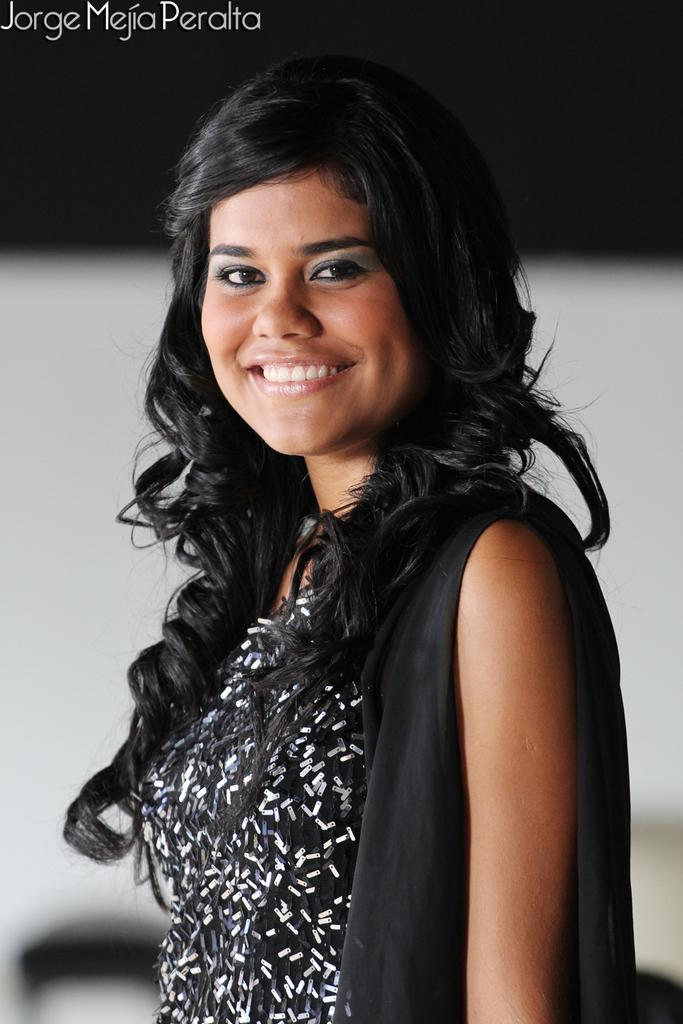Who is the main subject in the image? There is a woman in the center of the image. What is the woman wearing? The woman is wearing a black dress. Can you describe the background of the image? The background of the image is blurred. What can be seen at the top left of the image? There is some text at the top left of the image. How many cards does the woman have in her hand in the image? There are no cards visible in the image; the woman is not holding anything. What type of fan is present in the image? There is no fan present in the image. 